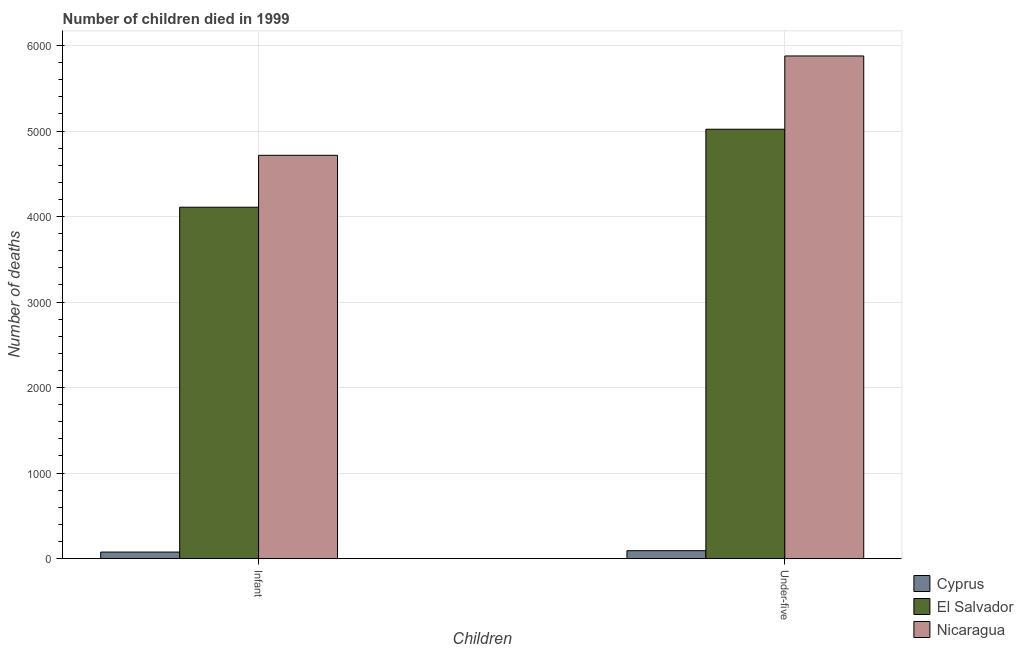Are the number of bars per tick equal to the number of legend labels?
Provide a succinct answer. Yes. How many bars are there on the 1st tick from the right?
Offer a terse response. 3. What is the label of the 1st group of bars from the left?
Your answer should be compact. Infant. What is the number of infant deaths in El Salvador?
Ensure brevity in your answer.  4109. Across all countries, what is the maximum number of infant deaths?
Your response must be concise. 4716. Across all countries, what is the minimum number of infant deaths?
Provide a short and direct response. 76. In which country was the number of under-five deaths maximum?
Your response must be concise. Nicaragua. In which country was the number of under-five deaths minimum?
Your answer should be very brief. Cyprus. What is the total number of infant deaths in the graph?
Offer a terse response. 8901. What is the difference between the number of infant deaths in El Salvador and that in Nicaragua?
Keep it short and to the point. -607. What is the difference between the number of under-five deaths in Nicaragua and the number of infant deaths in Cyprus?
Make the answer very short. 5802. What is the average number of infant deaths per country?
Make the answer very short. 2967. What is the difference between the number of under-five deaths and number of infant deaths in El Salvador?
Provide a short and direct response. 912. What is the ratio of the number of infant deaths in Nicaragua to that in Cyprus?
Ensure brevity in your answer.  62.05. What does the 2nd bar from the left in Infant represents?
Offer a terse response. El Salvador. What does the 1st bar from the right in Infant represents?
Ensure brevity in your answer.  Nicaragua. Are the values on the major ticks of Y-axis written in scientific E-notation?
Your answer should be compact. No. Does the graph contain any zero values?
Provide a short and direct response. No. Does the graph contain grids?
Offer a terse response. Yes. How are the legend labels stacked?
Your response must be concise. Vertical. What is the title of the graph?
Your answer should be compact. Number of children died in 1999. What is the label or title of the X-axis?
Provide a succinct answer. Children. What is the label or title of the Y-axis?
Keep it short and to the point. Number of deaths. What is the Number of deaths in El Salvador in Infant?
Your response must be concise. 4109. What is the Number of deaths of Nicaragua in Infant?
Provide a short and direct response. 4716. What is the Number of deaths in Cyprus in Under-five?
Make the answer very short. 92. What is the Number of deaths of El Salvador in Under-five?
Your answer should be very brief. 5021. What is the Number of deaths in Nicaragua in Under-five?
Provide a short and direct response. 5878. Across all Children, what is the maximum Number of deaths of Cyprus?
Your response must be concise. 92. Across all Children, what is the maximum Number of deaths of El Salvador?
Offer a very short reply. 5021. Across all Children, what is the maximum Number of deaths of Nicaragua?
Your response must be concise. 5878. Across all Children, what is the minimum Number of deaths in El Salvador?
Your response must be concise. 4109. Across all Children, what is the minimum Number of deaths in Nicaragua?
Ensure brevity in your answer.  4716. What is the total Number of deaths in Cyprus in the graph?
Provide a short and direct response. 168. What is the total Number of deaths in El Salvador in the graph?
Give a very brief answer. 9130. What is the total Number of deaths in Nicaragua in the graph?
Your answer should be very brief. 1.06e+04. What is the difference between the Number of deaths of El Salvador in Infant and that in Under-five?
Give a very brief answer. -912. What is the difference between the Number of deaths of Nicaragua in Infant and that in Under-five?
Make the answer very short. -1162. What is the difference between the Number of deaths in Cyprus in Infant and the Number of deaths in El Salvador in Under-five?
Your answer should be very brief. -4945. What is the difference between the Number of deaths in Cyprus in Infant and the Number of deaths in Nicaragua in Under-five?
Ensure brevity in your answer.  -5802. What is the difference between the Number of deaths of El Salvador in Infant and the Number of deaths of Nicaragua in Under-five?
Provide a short and direct response. -1769. What is the average Number of deaths in Cyprus per Children?
Your response must be concise. 84. What is the average Number of deaths in El Salvador per Children?
Your response must be concise. 4565. What is the average Number of deaths of Nicaragua per Children?
Your response must be concise. 5297. What is the difference between the Number of deaths of Cyprus and Number of deaths of El Salvador in Infant?
Provide a short and direct response. -4033. What is the difference between the Number of deaths of Cyprus and Number of deaths of Nicaragua in Infant?
Provide a succinct answer. -4640. What is the difference between the Number of deaths of El Salvador and Number of deaths of Nicaragua in Infant?
Give a very brief answer. -607. What is the difference between the Number of deaths in Cyprus and Number of deaths in El Salvador in Under-five?
Make the answer very short. -4929. What is the difference between the Number of deaths in Cyprus and Number of deaths in Nicaragua in Under-five?
Give a very brief answer. -5786. What is the difference between the Number of deaths of El Salvador and Number of deaths of Nicaragua in Under-five?
Offer a terse response. -857. What is the ratio of the Number of deaths in Cyprus in Infant to that in Under-five?
Make the answer very short. 0.83. What is the ratio of the Number of deaths of El Salvador in Infant to that in Under-five?
Make the answer very short. 0.82. What is the ratio of the Number of deaths in Nicaragua in Infant to that in Under-five?
Your answer should be compact. 0.8. What is the difference between the highest and the second highest Number of deaths in El Salvador?
Ensure brevity in your answer.  912. What is the difference between the highest and the second highest Number of deaths in Nicaragua?
Keep it short and to the point. 1162. What is the difference between the highest and the lowest Number of deaths in Cyprus?
Make the answer very short. 16. What is the difference between the highest and the lowest Number of deaths of El Salvador?
Make the answer very short. 912. What is the difference between the highest and the lowest Number of deaths in Nicaragua?
Make the answer very short. 1162. 